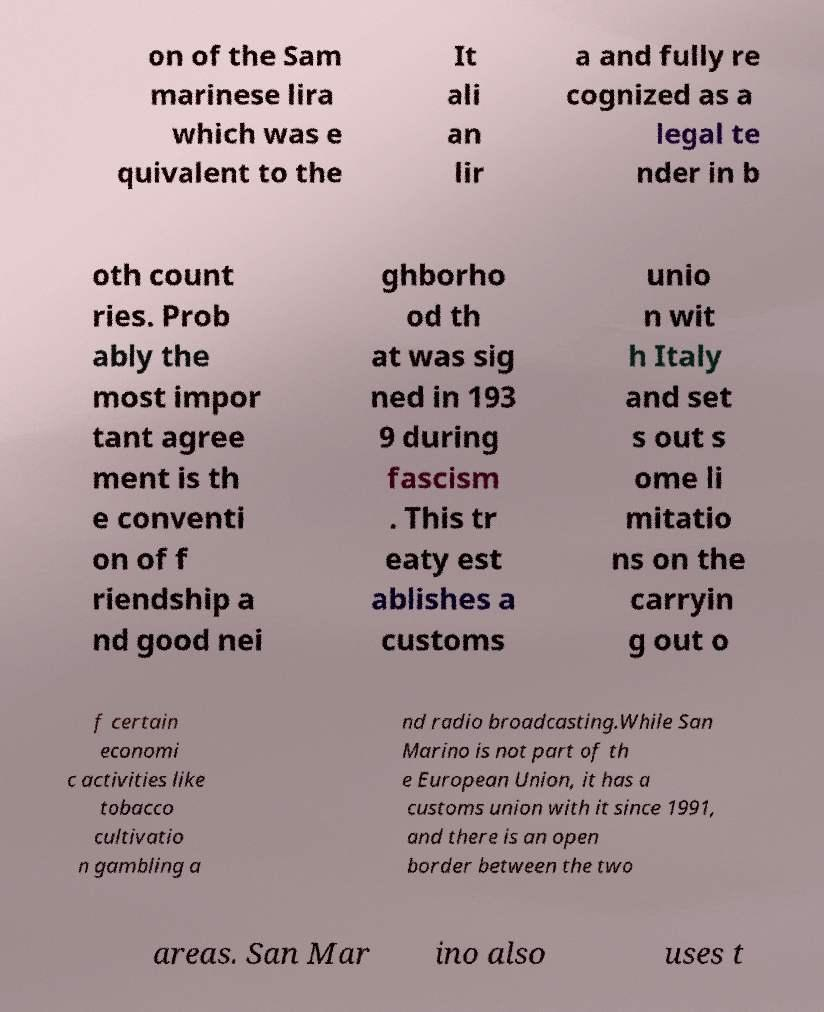Could you assist in decoding the text presented in this image and type it out clearly? on of the Sam marinese lira which was e quivalent to the It ali an lir a and fully re cognized as a legal te nder in b oth count ries. Prob ably the most impor tant agree ment is th e conventi on of f riendship a nd good nei ghborho od th at was sig ned in 193 9 during fascism . This tr eaty est ablishes a customs unio n wit h Italy and set s out s ome li mitatio ns on the carryin g out o f certain economi c activities like tobacco cultivatio n gambling a nd radio broadcasting.While San Marino is not part of th e European Union, it has a customs union with it since 1991, and there is an open border between the two areas. San Mar ino also uses t 